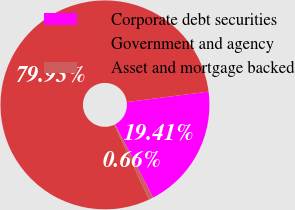<chart> <loc_0><loc_0><loc_500><loc_500><pie_chart><fcel>Corporate debt securities<fcel>Government and agency<fcel>Asset and mortgage backed<nl><fcel>19.41%<fcel>79.93%<fcel>0.66%<nl></chart> 